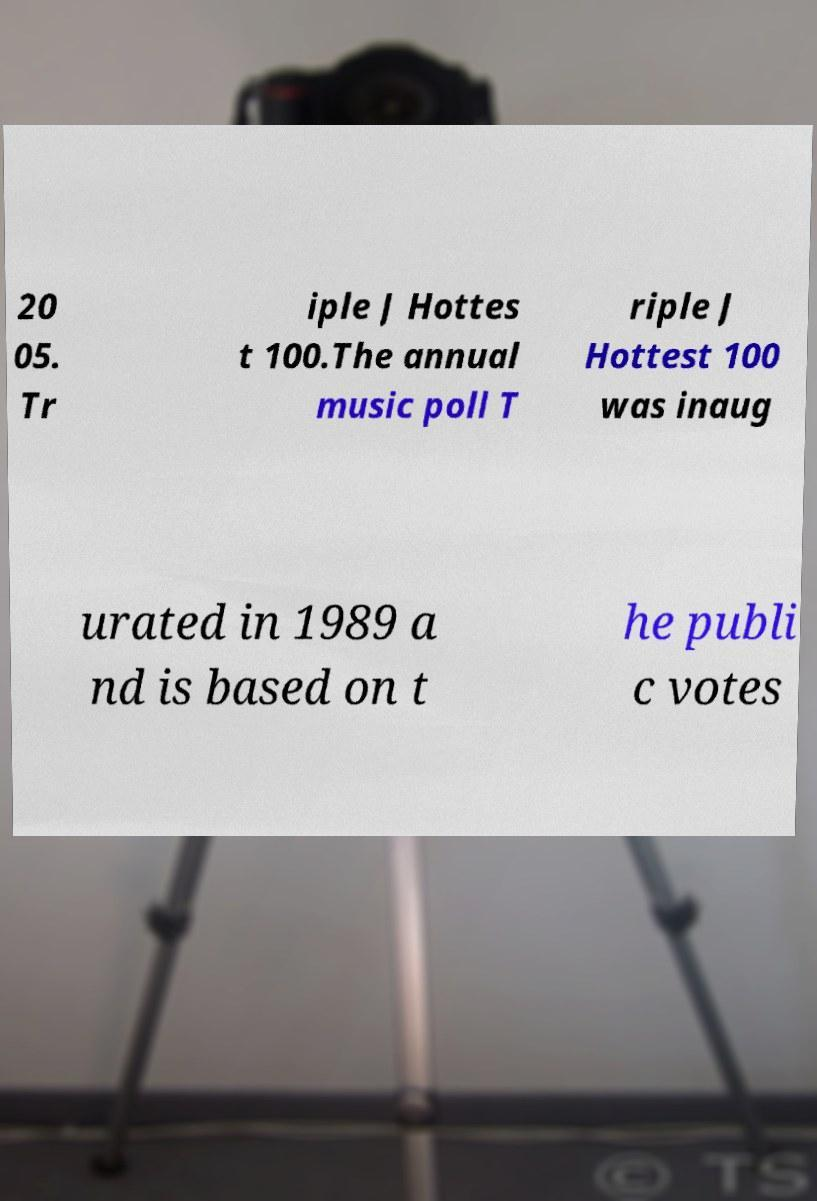Please read and relay the text visible in this image. What does it say? 20 05. Tr iple J Hottes t 100.The annual music poll T riple J Hottest 100 was inaug urated in 1989 a nd is based on t he publi c votes 